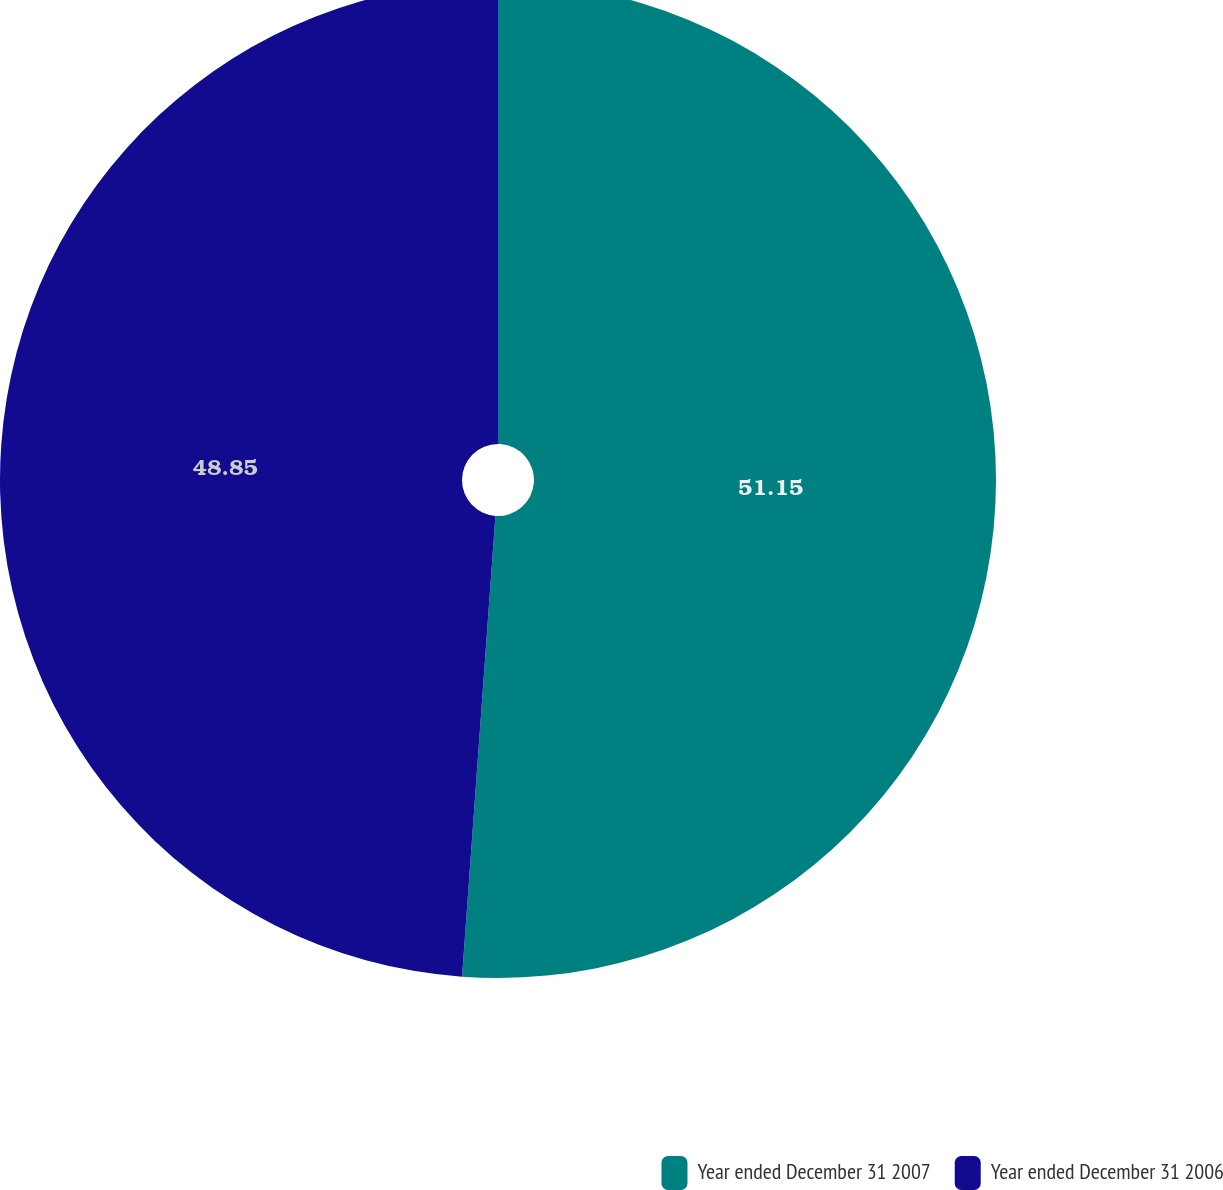<chart> <loc_0><loc_0><loc_500><loc_500><pie_chart><fcel>Year ended December 31 2007<fcel>Year ended December 31 2006<nl><fcel>51.15%<fcel>48.85%<nl></chart> 